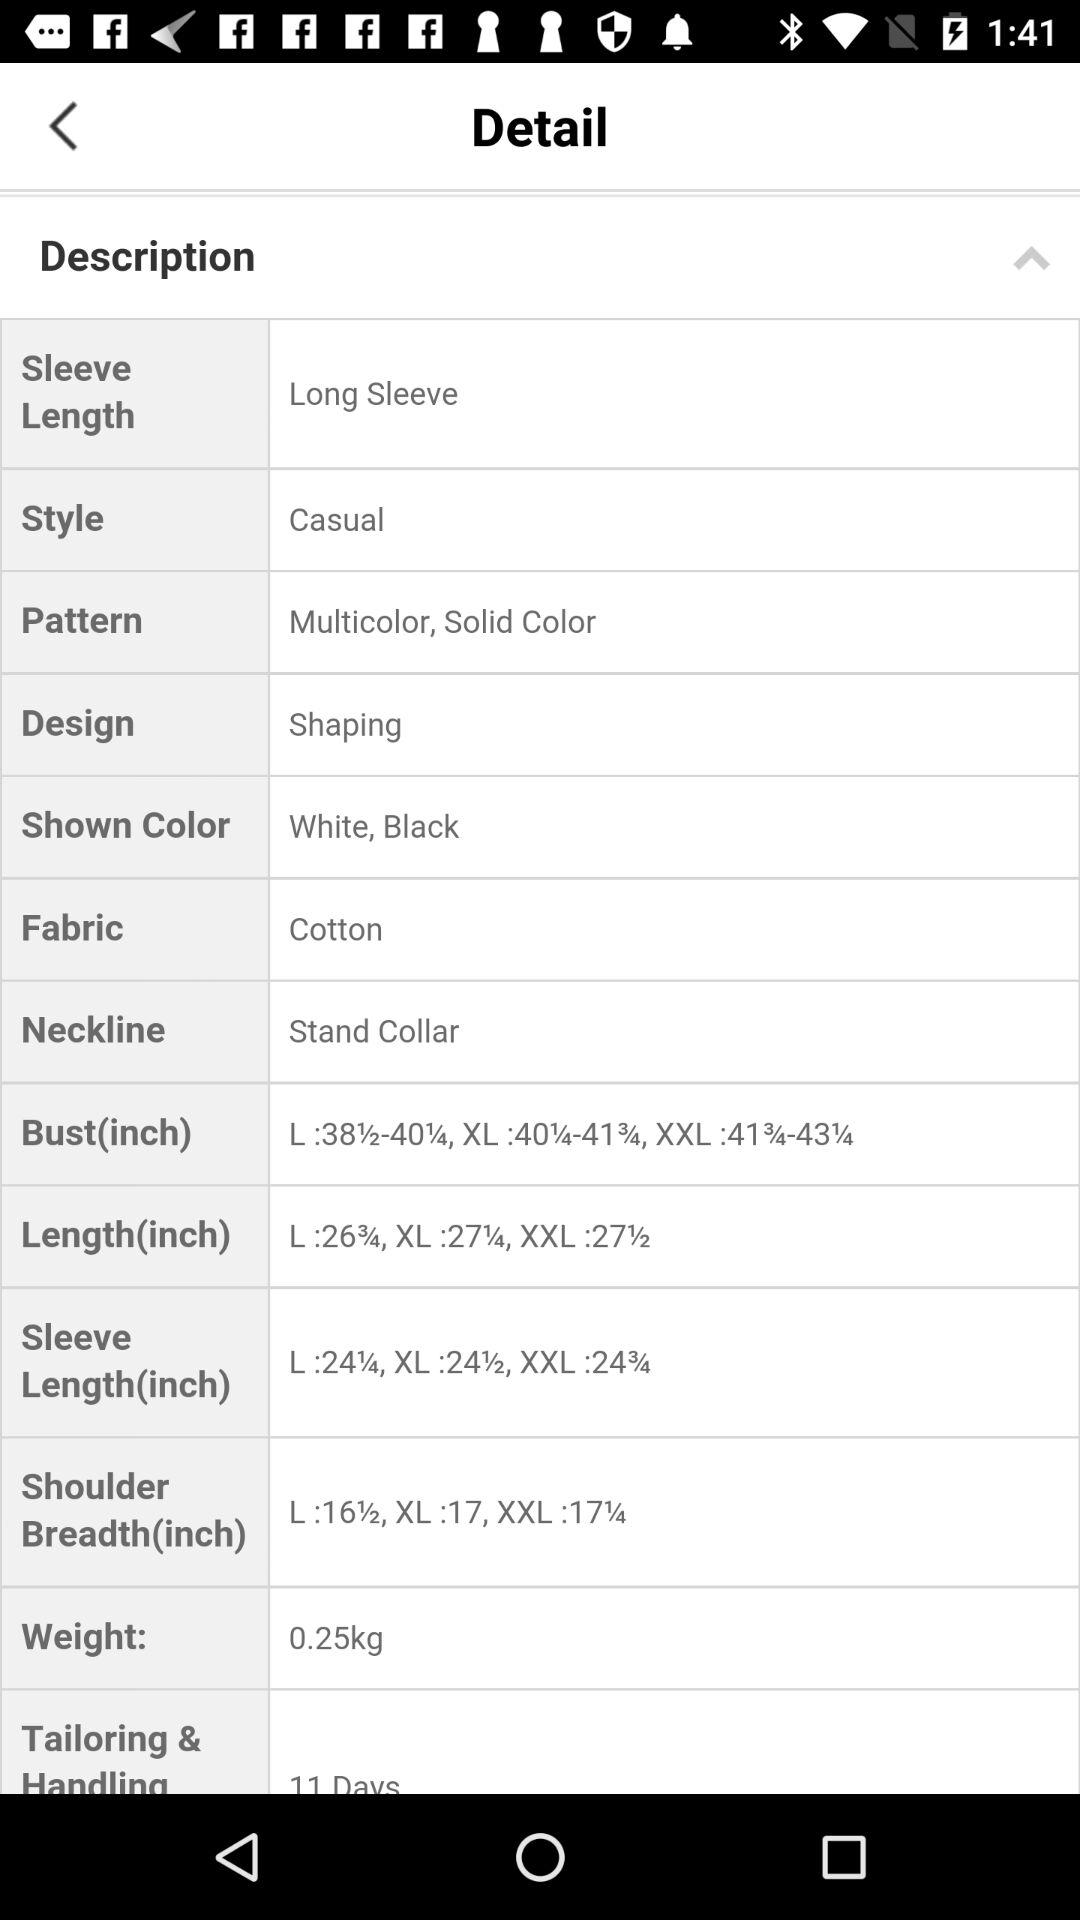What is the "Shown Color"? The shown colors are "White" and "Black". 